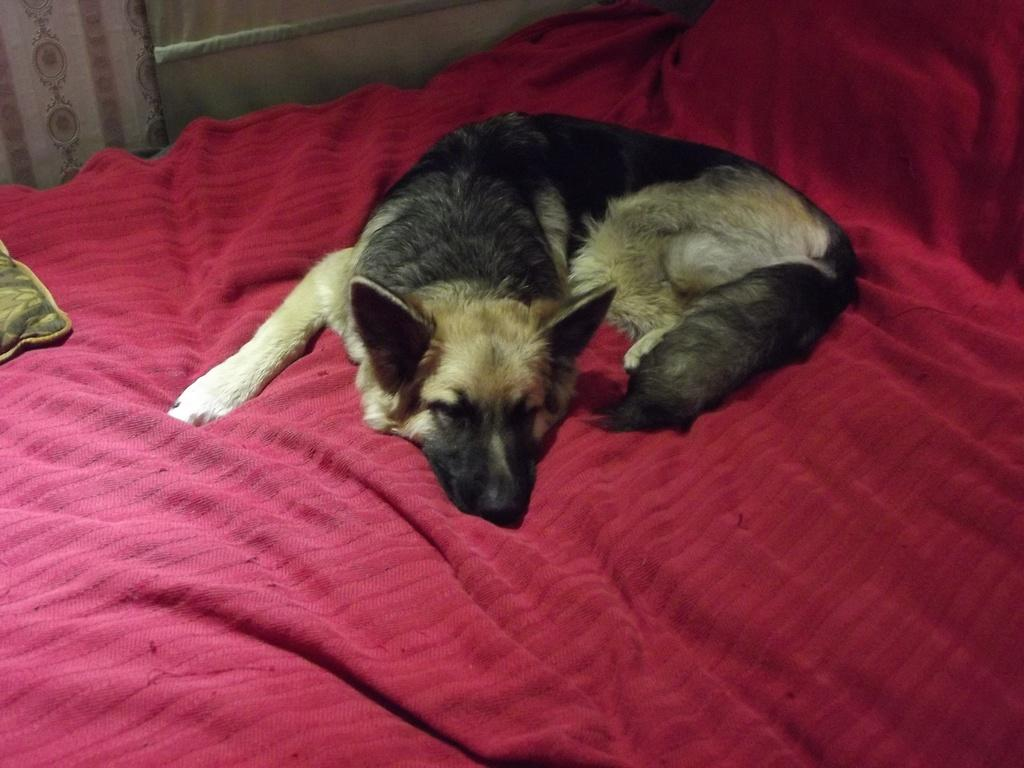What type of animal is in the image? There is a dog in the image. What colors can be seen on the dog? The dog is black and brown in color. Where is the dog located in the image? The dog is laying on a bed. What color is the bed sheet? The bed sheet is red in color. What can be seen on the left side of the image? There is a curtain on the left side of the image. How many oranges are on the bed with the dog? There are no oranges present in the image; it only features a dog laying on a bed with a red bed sheet. 